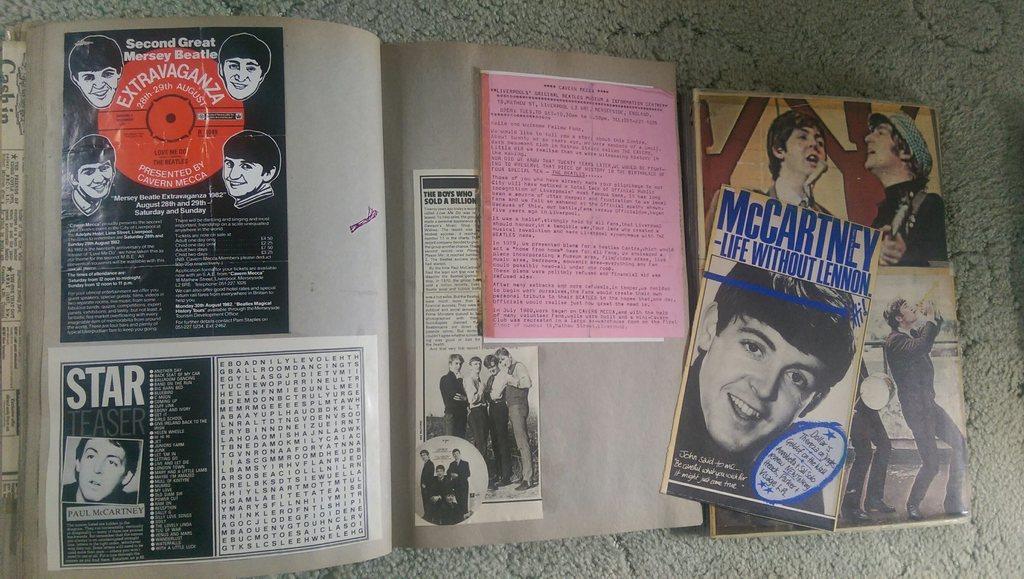What is the article mentioning life without?
Your response must be concise. Lennon. 